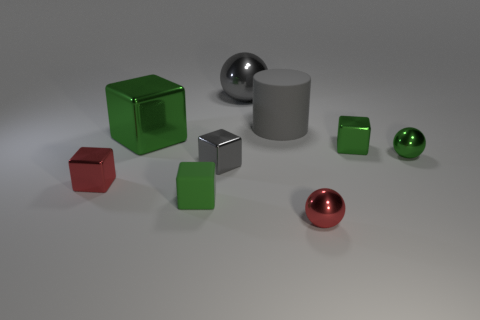How many things are either gray metal things that are in front of the large gray metal sphere or brown cylinders?
Make the answer very short. 1. What is the size of the green shiny object that is to the right of the tiny green shiny block?
Make the answer very short. Small. There is a gray cylinder; is its size the same as the gray metallic object that is in front of the tiny green metallic ball?
Give a very brief answer. No. The metal cube that is left of the green shiny cube that is on the left side of the tiny gray block is what color?
Your answer should be compact. Red. What number of other objects are there of the same color as the big sphere?
Offer a terse response. 2. What is the size of the gray sphere?
Ensure brevity in your answer.  Large. Is the number of balls behind the tiny gray thing greater than the number of green balls that are to the right of the green metal sphere?
Keep it short and to the point. Yes. There is a gray cylinder on the right side of the small red cube; how many gray metallic objects are behind it?
Provide a succinct answer. 1. There is a gray thing to the left of the gray sphere; does it have the same shape as the tiny rubber object?
Keep it short and to the point. Yes. What is the material of the other large thing that is the same shape as the green rubber thing?
Provide a succinct answer. Metal. 